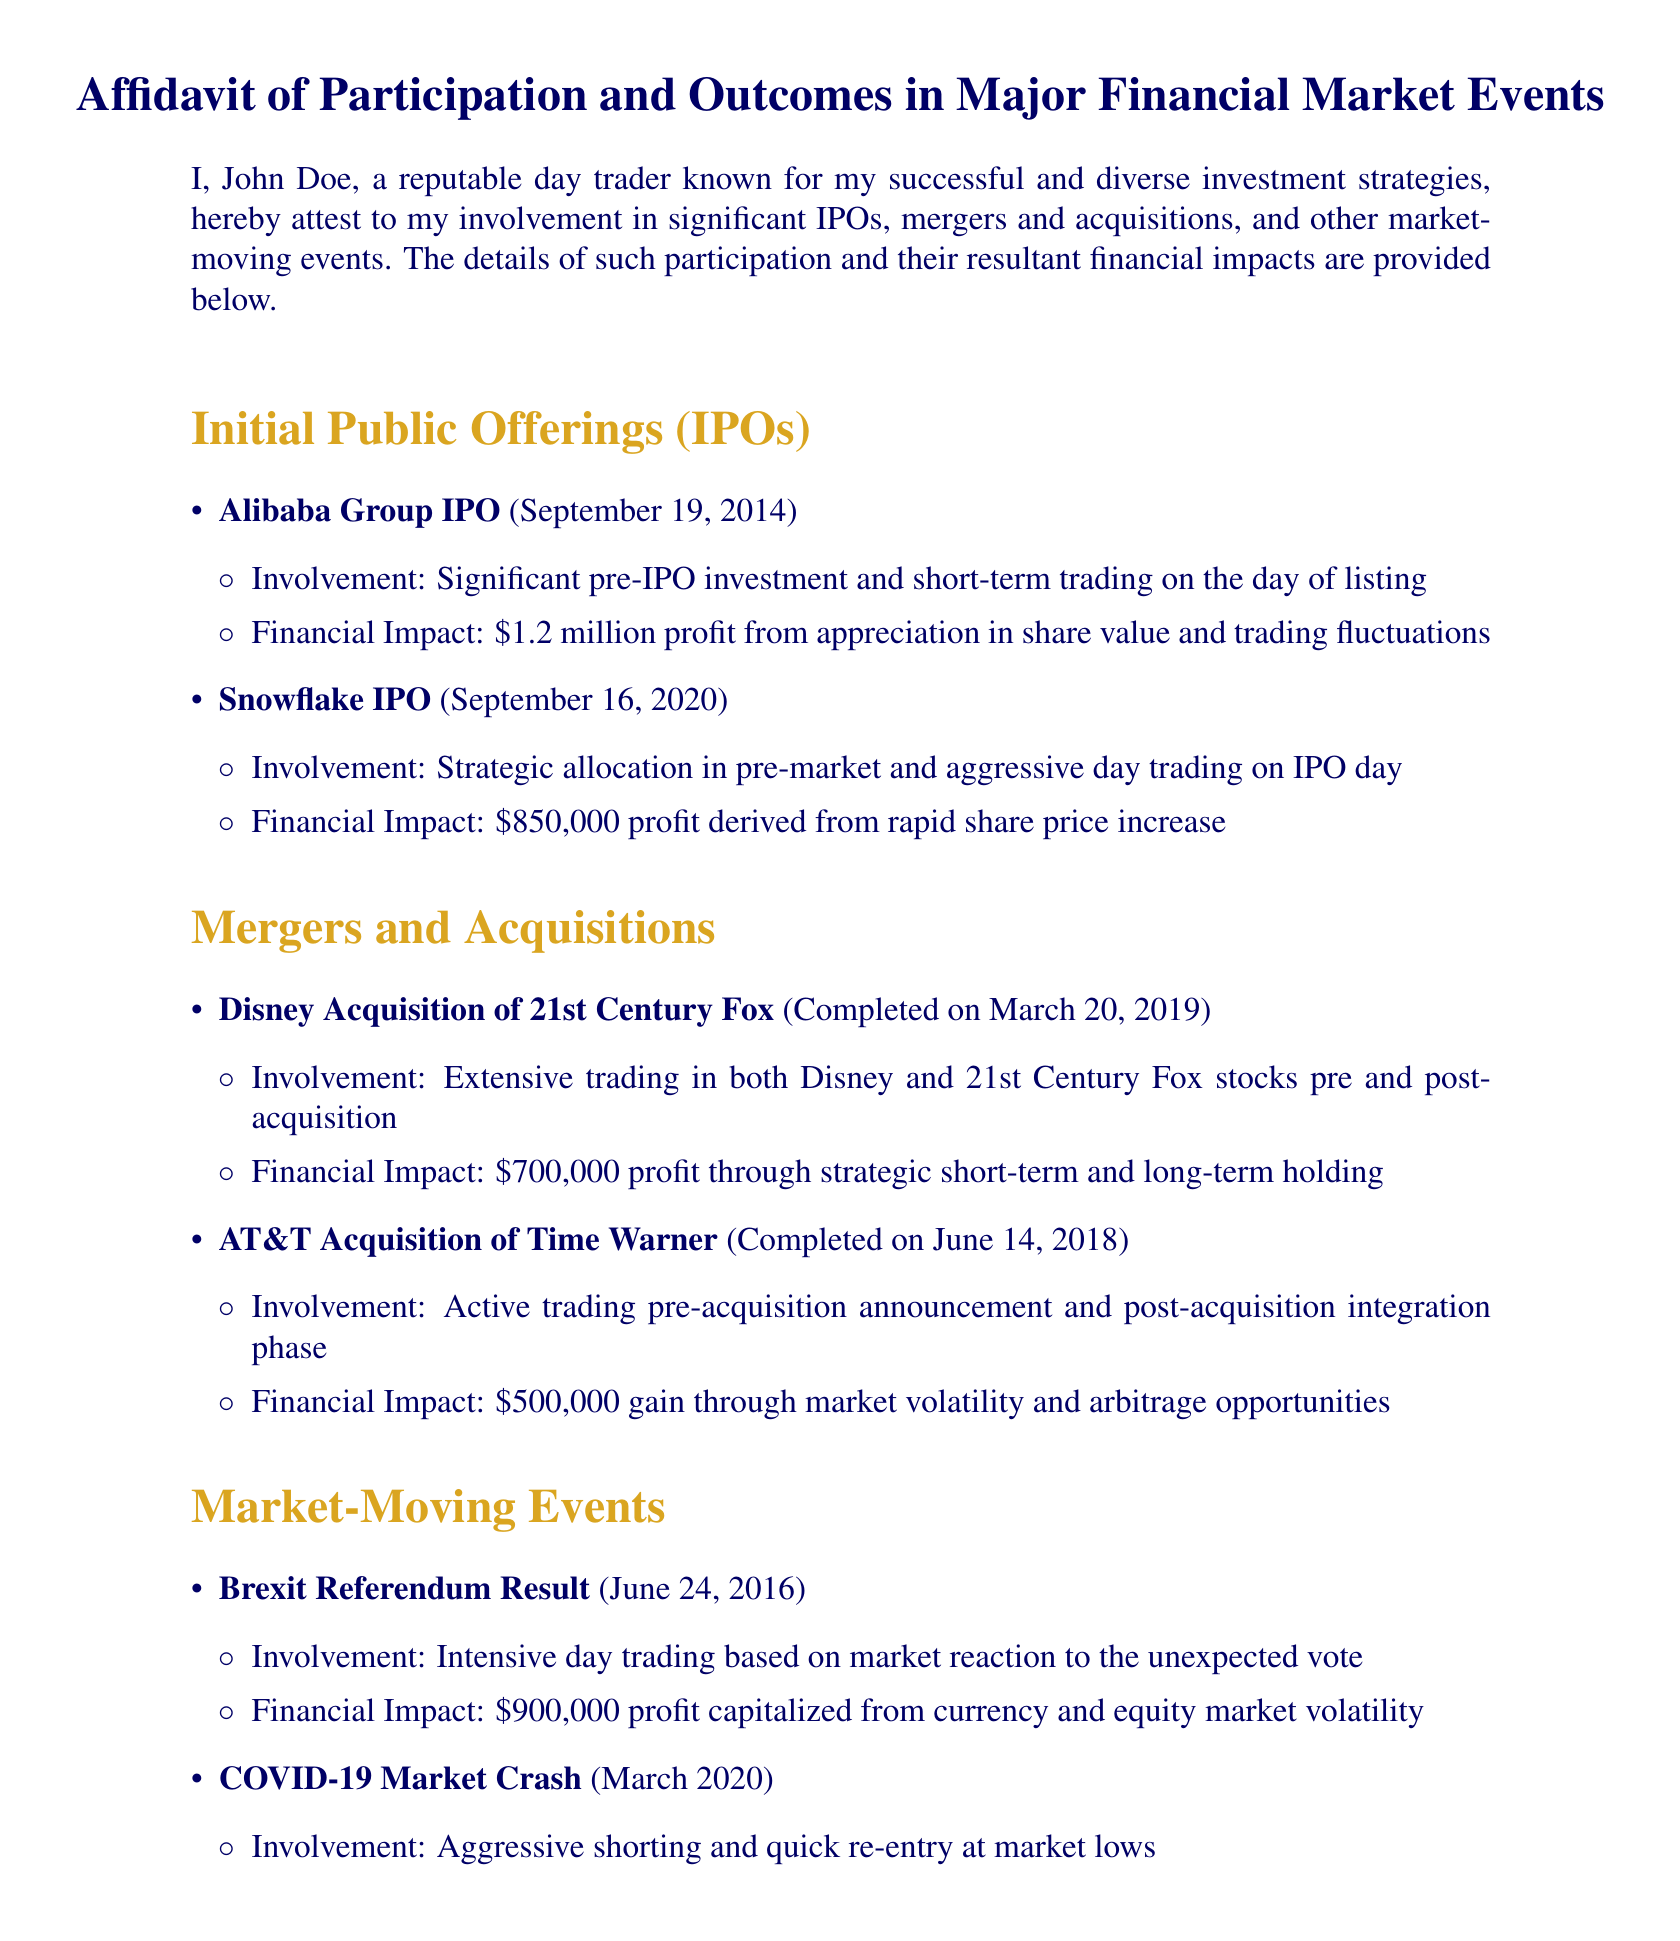What was the profit from the Alibaba Group IPO? The document states a profit of \$1.2 million from the Alibaba Group IPO.
Answer: \$1.2 million When did the Snowflake IPO take place? The document specifies that the Snowflake IPO occurred on September 16, 2020.
Answer: September 16, 2020 What was the involvement in the Disney acquisition of 21st Century Fox? The document mentions extensive trading in both Disney and 21st Century Fox stocks pre and post-acquisition.
Answer: Extensive trading What was the total financial impact from the COVID-19 Market Crash? The document indicates a net gain of \$1.5 million derived from the market rebounds during the COVID-19 Market Crash.
Answer: \$1.5 million How much profit was made from the Brexit Referendum result? According to the document, the profit from the Brexit Referendum result was \$900,000.
Answer: \$900,000 What type of events does the affidavit discuss? The document discusses IPOs, mergers and acquisitions, and market-moving events.
Answer: IPOs, mergers and acquisitions, market-moving events Who signed the affidavit? The document states that John Doe signed the affidavit.
Answer: John Doe What financial impact was associated with the AT&T acquisition of Time Warner? The document shows a financial impact of \$500,000 gain from market volatility and arbitrage opportunities.
Answer: \$500,000 What does the document certify about the information provided? The document certifies that the information is true and accurate to the best of the signer's knowledge and belief.
Answer: True and accurate How many significant IPOs are mentioned in the affidavit? The document mentions two significant IPOs: Alibaba Group and Snowflake.
Answer: Two 